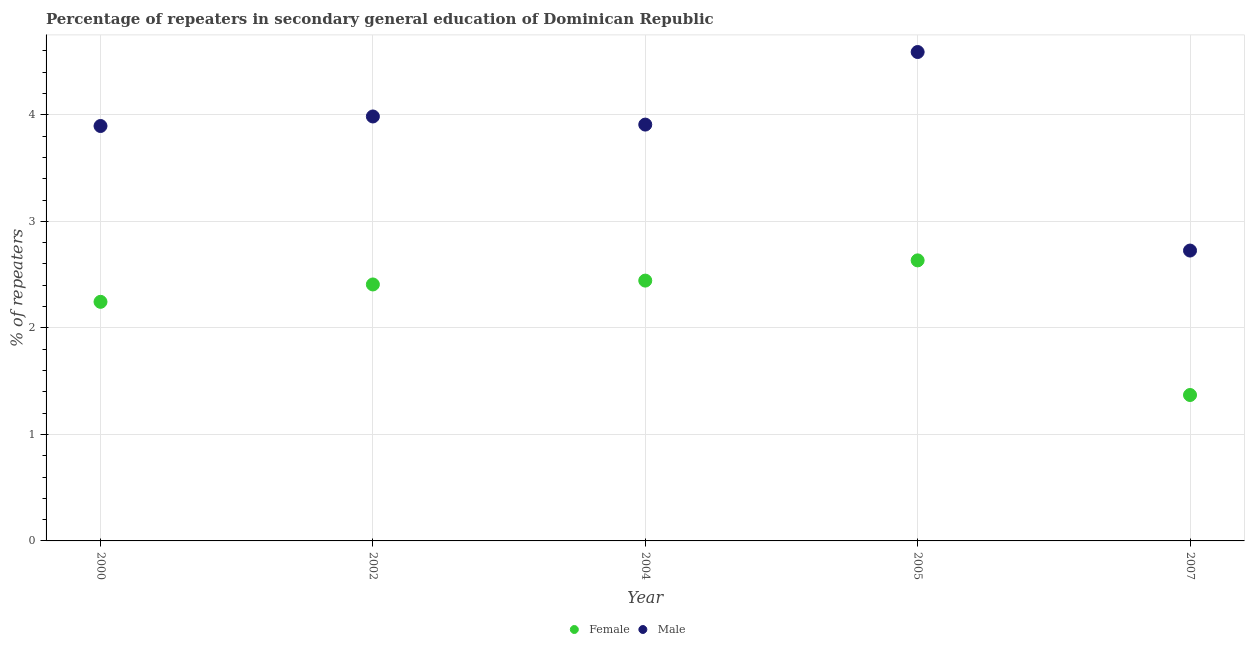How many different coloured dotlines are there?
Give a very brief answer. 2. What is the percentage of male repeaters in 2004?
Keep it short and to the point. 3.91. Across all years, what is the maximum percentage of female repeaters?
Provide a succinct answer. 2.63. Across all years, what is the minimum percentage of female repeaters?
Give a very brief answer. 1.37. In which year was the percentage of female repeaters minimum?
Your answer should be very brief. 2007. What is the total percentage of female repeaters in the graph?
Provide a succinct answer. 11.1. What is the difference between the percentage of female repeaters in 2005 and that in 2007?
Your answer should be compact. 1.26. What is the difference between the percentage of female repeaters in 2002 and the percentage of male repeaters in 2005?
Your answer should be compact. -2.18. What is the average percentage of female repeaters per year?
Your answer should be very brief. 2.22. In the year 2000, what is the difference between the percentage of female repeaters and percentage of male repeaters?
Your answer should be very brief. -1.65. In how many years, is the percentage of male repeaters greater than 4.2 %?
Offer a very short reply. 1. What is the ratio of the percentage of female repeaters in 2002 to that in 2007?
Make the answer very short. 1.76. Is the difference between the percentage of female repeaters in 2000 and 2002 greater than the difference between the percentage of male repeaters in 2000 and 2002?
Keep it short and to the point. No. What is the difference between the highest and the second highest percentage of female repeaters?
Ensure brevity in your answer.  0.19. What is the difference between the highest and the lowest percentage of female repeaters?
Provide a short and direct response. 1.26. Is the sum of the percentage of male repeaters in 2000 and 2005 greater than the maximum percentage of female repeaters across all years?
Keep it short and to the point. Yes. How are the legend labels stacked?
Offer a terse response. Horizontal. What is the title of the graph?
Give a very brief answer. Percentage of repeaters in secondary general education of Dominican Republic. Does "Goods" appear as one of the legend labels in the graph?
Your answer should be compact. No. What is the label or title of the Y-axis?
Ensure brevity in your answer.  % of repeaters. What is the % of repeaters in Female in 2000?
Keep it short and to the point. 2.24. What is the % of repeaters of Male in 2000?
Your answer should be compact. 3.9. What is the % of repeaters in Female in 2002?
Give a very brief answer. 2.41. What is the % of repeaters of Male in 2002?
Ensure brevity in your answer.  3.98. What is the % of repeaters in Female in 2004?
Offer a very short reply. 2.44. What is the % of repeaters of Male in 2004?
Your answer should be compact. 3.91. What is the % of repeaters in Female in 2005?
Keep it short and to the point. 2.63. What is the % of repeaters of Male in 2005?
Give a very brief answer. 4.59. What is the % of repeaters in Female in 2007?
Provide a short and direct response. 1.37. What is the % of repeaters in Male in 2007?
Give a very brief answer. 2.73. Across all years, what is the maximum % of repeaters in Female?
Provide a succinct answer. 2.63. Across all years, what is the maximum % of repeaters of Male?
Provide a succinct answer. 4.59. Across all years, what is the minimum % of repeaters in Female?
Give a very brief answer. 1.37. Across all years, what is the minimum % of repeaters in Male?
Make the answer very short. 2.73. What is the total % of repeaters in Female in the graph?
Make the answer very short. 11.1. What is the total % of repeaters in Male in the graph?
Ensure brevity in your answer.  19.1. What is the difference between the % of repeaters of Female in 2000 and that in 2002?
Your response must be concise. -0.16. What is the difference between the % of repeaters of Male in 2000 and that in 2002?
Your answer should be compact. -0.09. What is the difference between the % of repeaters in Female in 2000 and that in 2004?
Your response must be concise. -0.2. What is the difference between the % of repeaters in Male in 2000 and that in 2004?
Provide a short and direct response. -0.01. What is the difference between the % of repeaters in Female in 2000 and that in 2005?
Make the answer very short. -0.39. What is the difference between the % of repeaters in Male in 2000 and that in 2005?
Provide a short and direct response. -0.69. What is the difference between the % of repeaters in Female in 2000 and that in 2007?
Keep it short and to the point. 0.87. What is the difference between the % of repeaters of Male in 2000 and that in 2007?
Offer a terse response. 1.17. What is the difference between the % of repeaters of Female in 2002 and that in 2004?
Give a very brief answer. -0.04. What is the difference between the % of repeaters of Male in 2002 and that in 2004?
Offer a terse response. 0.08. What is the difference between the % of repeaters in Female in 2002 and that in 2005?
Give a very brief answer. -0.23. What is the difference between the % of repeaters of Male in 2002 and that in 2005?
Your answer should be compact. -0.6. What is the difference between the % of repeaters in Female in 2002 and that in 2007?
Your answer should be compact. 1.04. What is the difference between the % of repeaters of Male in 2002 and that in 2007?
Keep it short and to the point. 1.26. What is the difference between the % of repeaters in Female in 2004 and that in 2005?
Provide a short and direct response. -0.19. What is the difference between the % of repeaters of Male in 2004 and that in 2005?
Your response must be concise. -0.68. What is the difference between the % of repeaters in Female in 2004 and that in 2007?
Your answer should be compact. 1.07. What is the difference between the % of repeaters in Male in 2004 and that in 2007?
Offer a very short reply. 1.18. What is the difference between the % of repeaters of Female in 2005 and that in 2007?
Offer a terse response. 1.26. What is the difference between the % of repeaters in Male in 2005 and that in 2007?
Offer a terse response. 1.86. What is the difference between the % of repeaters in Female in 2000 and the % of repeaters in Male in 2002?
Give a very brief answer. -1.74. What is the difference between the % of repeaters of Female in 2000 and the % of repeaters of Male in 2004?
Make the answer very short. -1.66. What is the difference between the % of repeaters in Female in 2000 and the % of repeaters in Male in 2005?
Your answer should be compact. -2.35. What is the difference between the % of repeaters of Female in 2000 and the % of repeaters of Male in 2007?
Make the answer very short. -0.48. What is the difference between the % of repeaters in Female in 2002 and the % of repeaters in Male in 2004?
Offer a very short reply. -1.5. What is the difference between the % of repeaters of Female in 2002 and the % of repeaters of Male in 2005?
Make the answer very short. -2.18. What is the difference between the % of repeaters in Female in 2002 and the % of repeaters in Male in 2007?
Keep it short and to the point. -0.32. What is the difference between the % of repeaters of Female in 2004 and the % of repeaters of Male in 2005?
Make the answer very short. -2.15. What is the difference between the % of repeaters in Female in 2004 and the % of repeaters in Male in 2007?
Offer a terse response. -0.28. What is the difference between the % of repeaters of Female in 2005 and the % of repeaters of Male in 2007?
Your answer should be very brief. -0.09. What is the average % of repeaters of Female per year?
Offer a terse response. 2.22. What is the average % of repeaters of Male per year?
Your answer should be compact. 3.82. In the year 2000, what is the difference between the % of repeaters of Female and % of repeaters of Male?
Your answer should be very brief. -1.65. In the year 2002, what is the difference between the % of repeaters of Female and % of repeaters of Male?
Make the answer very short. -1.58. In the year 2004, what is the difference between the % of repeaters of Female and % of repeaters of Male?
Your answer should be compact. -1.46. In the year 2005, what is the difference between the % of repeaters of Female and % of repeaters of Male?
Keep it short and to the point. -1.96. In the year 2007, what is the difference between the % of repeaters in Female and % of repeaters in Male?
Offer a terse response. -1.36. What is the ratio of the % of repeaters in Female in 2000 to that in 2002?
Give a very brief answer. 0.93. What is the ratio of the % of repeaters of Male in 2000 to that in 2002?
Make the answer very short. 0.98. What is the ratio of the % of repeaters of Female in 2000 to that in 2004?
Ensure brevity in your answer.  0.92. What is the ratio of the % of repeaters in Female in 2000 to that in 2005?
Ensure brevity in your answer.  0.85. What is the ratio of the % of repeaters of Male in 2000 to that in 2005?
Ensure brevity in your answer.  0.85. What is the ratio of the % of repeaters in Female in 2000 to that in 2007?
Make the answer very short. 1.64. What is the ratio of the % of repeaters in Male in 2000 to that in 2007?
Provide a succinct answer. 1.43. What is the ratio of the % of repeaters in Female in 2002 to that in 2004?
Provide a succinct answer. 0.99. What is the ratio of the % of repeaters of Male in 2002 to that in 2004?
Provide a short and direct response. 1.02. What is the ratio of the % of repeaters of Female in 2002 to that in 2005?
Your answer should be compact. 0.91. What is the ratio of the % of repeaters of Male in 2002 to that in 2005?
Give a very brief answer. 0.87. What is the ratio of the % of repeaters in Female in 2002 to that in 2007?
Give a very brief answer. 1.76. What is the ratio of the % of repeaters in Male in 2002 to that in 2007?
Provide a succinct answer. 1.46. What is the ratio of the % of repeaters of Female in 2004 to that in 2005?
Make the answer very short. 0.93. What is the ratio of the % of repeaters of Male in 2004 to that in 2005?
Make the answer very short. 0.85. What is the ratio of the % of repeaters in Female in 2004 to that in 2007?
Your response must be concise. 1.78. What is the ratio of the % of repeaters in Male in 2004 to that in 2007?
Provide a short and direct response. 1.43. What is the ratio of the % of repeaters in Female in 2005 to that in 2007?
Make the answer very short. 1.92. What is the ratio of the % of repeaters of Male in 2005 to that in 2007?
Your response must be concise. 1.68. What is the difference between the highest and the second highest % of repeaters of Female?
Your response must be concise. 0.19. What is the difference between the highest and the second highest % of repeaters in Male?
Offer a terse response. 0.6. What is the difference between the highest and the lowest % of repeaters of Female?
Your answer should be compact. 1.26. What is the difference between the highest and the lowest % of repeaters in Male?
Make the answer very short. 1.86. 